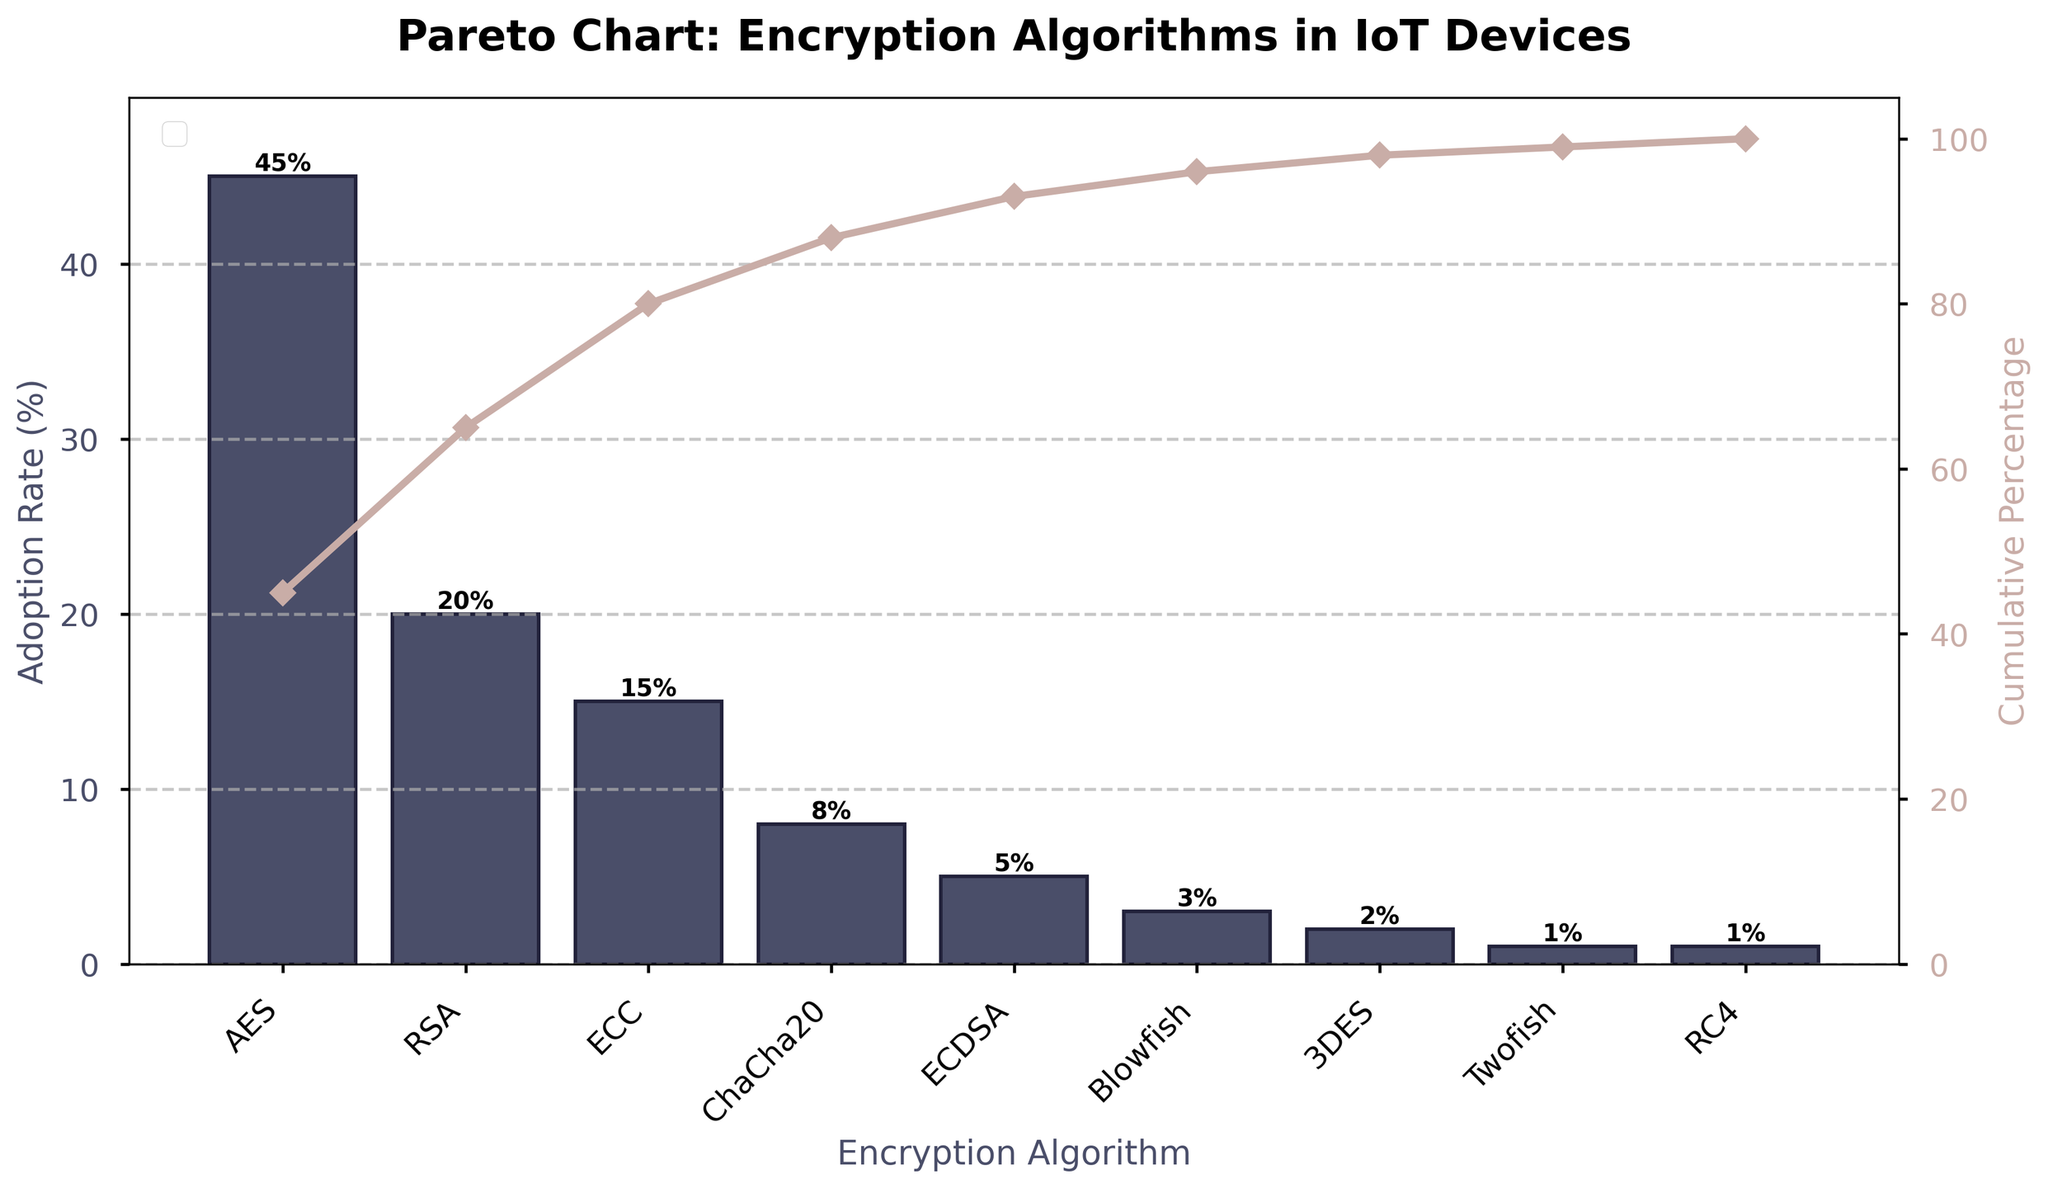What is the title of the chart? The title of a chart is usually found at the top and provides a brief description of what the chart is about. In this case, it says "Pareto Chart: Encryption Algorithms in IoT Devices".
Answer: Pareto Chart: Encryption Algorithms in IoT Devices Which encryption algorithm has the highest adoption rate? The algorithm with the tallest bar in the chart represents the highest adoption rate. In this chart, AES has the tallest bar.
Answer: AES What is the adoption rate of RSA? The height of the bar corresponding to RSA shows its adoption rate. According to the figure, the bar for RSA has an adoption rate of 20%.
Answer: 20% How many encryption algorithms have an adoption rate of 5% or less? By counting the bars with heights indicating an adoption rate of 5% or less, these are ECDSA (5%), Blowfish (3%), 3DES (2%), Twofish (1%), and RC4 (1%).
Answer: 5 What cumulative percentage does AES contribute to? The cumulative line for AES can be observed to find out its contribution. Since AES is the first in the sorted list, its cumulative percentage is the same as its adoption rate, which is 45%.
Answer: 45% What proportion of the total adoption rate is covered by AES, RSA, and ECC combined? Find the adoption rates of AES, RSA, and ECC and sum them up (45% + 20% + 15% = 80%). Then, calculate their combined proportion of the total rate, which is 80%.
Answer: 80% Which algorithm marks the point where the cumulative percentage first exceeds 90%? By following the cumulative percentage line and finding the first algorithm that makes it exceed 90%, it shows that after ECDSA (98%), the line exceeds 90%.
Answer: ECDSA How does the adoption rate of ChaCha20 compare with ECC? The height of ChaCha20’s bar (8%) is compared to ECC’s bar (15%), showing ECC has a higher adoption rate than ChaCha20.
Answer: ECC is higher What is the difference in adoption rates between the most and the least adopted encryption algorithms? Subtract the adoption rate of the least adopted (1%) from the most adopted (45%). The difference is 45% - 1% = 44%.
Answer: 44% What is the combined cumulative percentage of the top four encryption algorithms? Sum the individual adoption rates of the top four and convert to cumulative percentage: AES (45%) + RSA (20%) + ECC (15%) + ChaCha20 (8%) = 88%.
Answer: 88% 